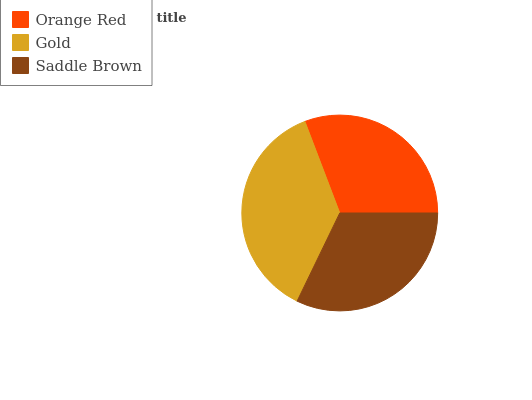Is Orange Red the minimum?
Answer yes or no. Yes. Is Gold the maximum?
Answer yes or no. Yes. Is Saddle Brown the minimum?
Answer yes or no. No. Is Saddle Brown the maximum?
Answer yes or no. No. Is Gold greater than Saddle Brown?
Answer yes or no. Yes. Is Saddle Brown less than Gold?
Answer yes or no. Yes. Is Saddle Brown greater than Gold?
Answer yes or no. No. Is Gold less than Saddle Brown?
Answer yes or no. No. Is Saddle Brown the high median?
Answer yes or no. Yes. Is Saddle Brown the low median?
Answer yes or no. Yes. Is Orange Red the high median?
Answer yes or no. No. Is Gold the low median?
Answer yes or no. No. 